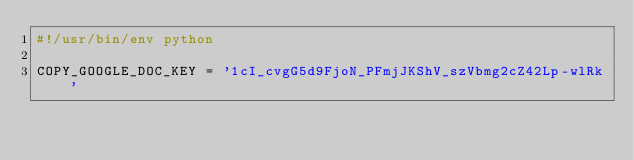<code> <loc_0><loc_0><loc_500><loc_500><_Python_>#!/usr/bin/env python

COPY_GOOGLE_DOC_KEY = '1cI_cvgG5d9FjoN_PFmjJKShV_szVbmg2cZ42Lp-wlRk'
</code> 